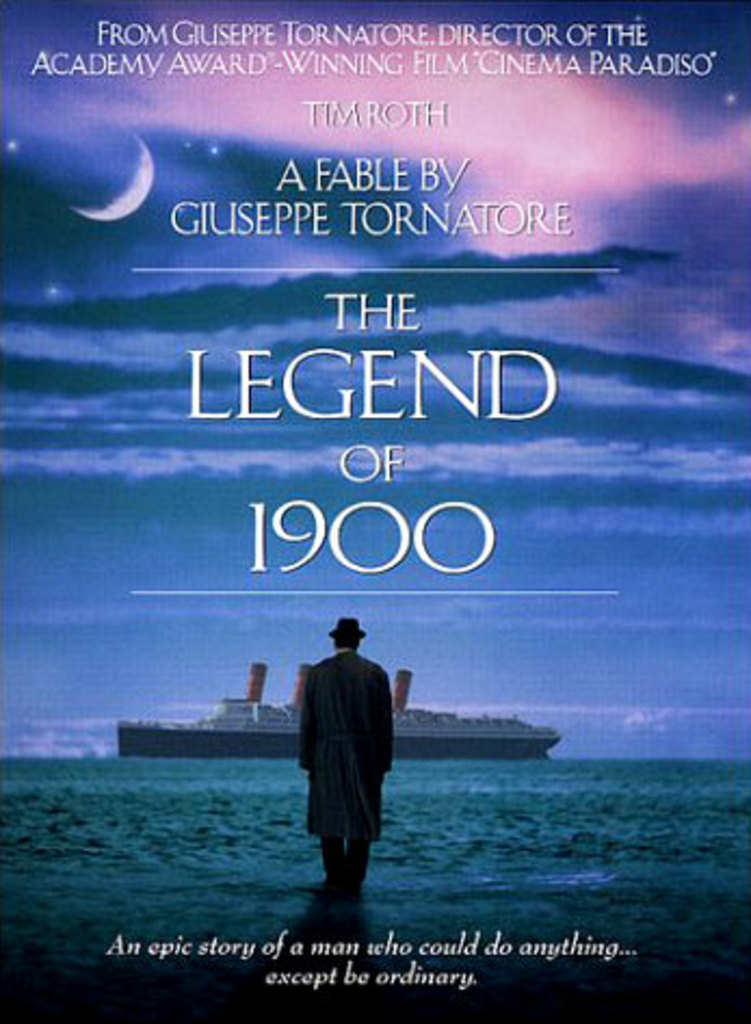What are the key elements in this picture? The image is a movie poster for 'The Legend of 1900', a film directed by Giuseppe Tornatore, who also directed the acclaimed 'Cinema Paradiso'. The poster features a large ocean liner on a vibrant blue ocean under a glowing full moon, which creates a striking visual metaphor for the extraordinary journey of the film's protagonist, played by Tim Roth. The film is labeled as a fable, indicating a whimsical or fantastical narrative. Essential details such as the film’s title and the compelling tagline, 'An epic story of a man who could do anything... except be ordinary', are prominently included to intrigue the viewer and hint at the unique nature of the story. 